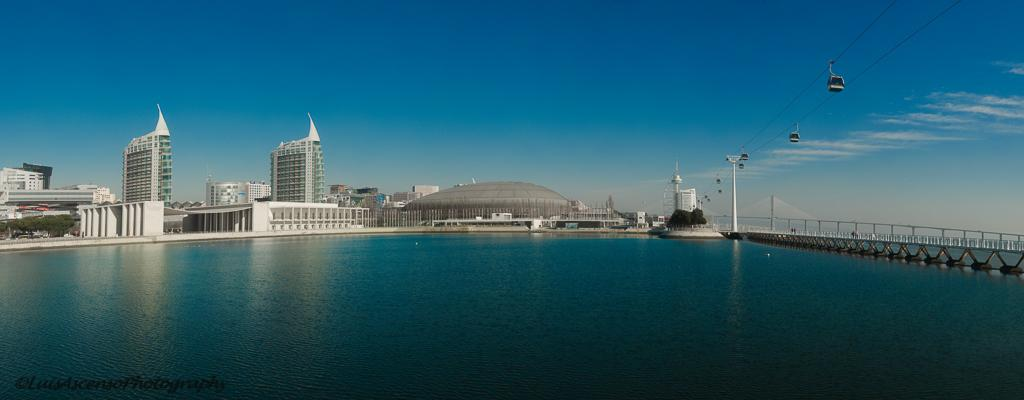What is the main feature of the landscape in the picture? There is water in the picture. What structure can be seen crossing the water? There is a bridge in the picture. What mode of transportation is visible in the picture? There is a ropeway in the picture. What can be seen in the distance behind the water and bridge? There are buildings in the background of the picture. What is the condition of the sky in the picture? The sky is clear and visible at the top of the picture. How many cats are sitting on the wheel in the picture? There is no wheel or cats present in the image. What type of amusement park ride can be seen near the bridge in the picture? There is no amusement park ride present in the image; it features a bridge, water, a ropeway, buildings, and a clear sky. 